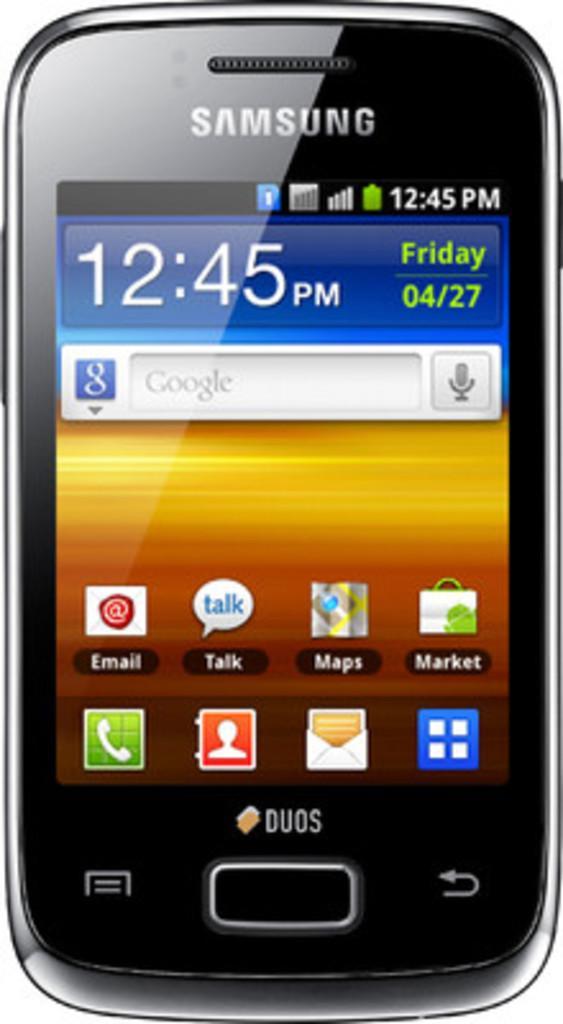In one or two sentences, can you explain what this image depicts? In this image there is a mobile phone, there is text on the mobile phone, there is the time and date displayed on the mobile phone, the background of the image is white in color. 